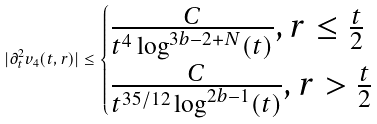<formula> <loc_0><loc_0><loc_500><loc_500>| \partial _ { t } ^ { 2 } v _ { 4 } ( t , r ) | \leq \begin{cases} \frac { C } { t ^ { 4 } \log ^ { 3 b - 2 + N } ( t ) } , r \leq \frac { t } { 2 } \\ \frac { C } { t ^ { 3 5 / 1 2 } \log ^ { 2 b - 1 } ( t ) } , r > \frac { t } { 2 } \end{cases}</formula> 